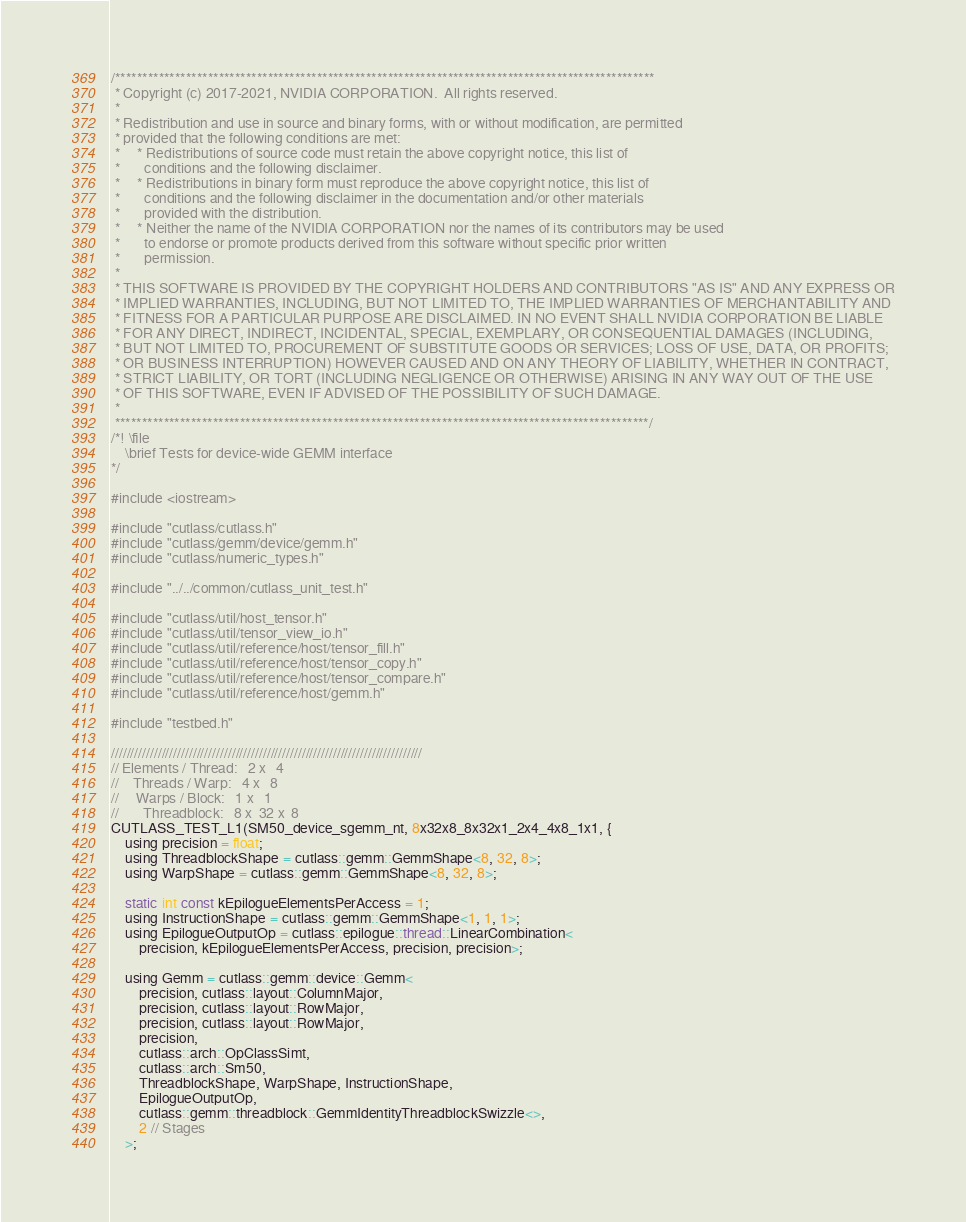Convert code to text. <code><loc_0><loc_0><loc_500><loc_500><_Cuda_>/***************************************************************************************************
 * Copyright (c) 2017-2021, NVIDIA CORPORATION.  All rights reserved.
 *
 * Redistribution and use in source and binary forms, with or without modification, are permitted
 * provided that the following conditions are met:
 *     * Redistributions of source code must retain the above copyright notice, this list of
 *       conditions and the following disclaimer.
 *     * Redistributions in binary form must reproduce the above copyright notice, this list of
 *       conditions and the following disclaimer in the documentation and/or other materials
 *       provided with the distribution.
 *     * Neither the name of the NVIDIA CORPORATION nor the names of its contributors may be used
 *       to endorse or promote products derived from this software without specific prior written
 *       permission.
 *
 * THIS SOFTWARE IS PROVIDED BY THE COPYRIGHT HOLDERS AND CONTRIBUTORS "AS IS" AND ANY EXPRESS OR
 * IMPLIED WARRANTIES, INCLUDING, BUT NOT LIMITED TO, THE IMPLIED WARRANTIES OF MERCHANTABILITY AND
 * FITNESS FOR A PARTICULAR PURPOSE ARE DISCLAIMED. IN NO EVENT SHALL NVIDIA CORPORATION BE LIABLE
 * FOR ANY DIRECT, INDIRECT, INCIDENTAL, SPECIAL, EXEMPLARY, OR CONSEQUENTIAL DAMAGES (INCLUDING,
 * BUT NOT LIMITED TO, PROCUREMENT OF SUBSTITUTE GOODS OR SERVICES; LOSS OF USE, DATA, OR PROFITS;
 * OR BUSINESS INTERRUPTION) HOWEVER CAUSED AND ON ANY THEORY OF LIABILITY, WHETHER IN CONTRACT,
 * STRICT LIABILITY, OR TORT (INCLUDING NEGLIGENCE OR OTHERWISE) ARISING IN ANY WAY OUT OF THE USE
 * OF THIS SOFTWARE, EVEN IF ADVISED OF THE POSSIBILITY OF SUCH DAMAGE.
 *
 **************************************************************************************************/
/*! \file
    \brief Tests for device-wide GEMM interface
*/

#include <iostream>

#include "cutlass/cutlass.h"
#include "cutlass/gemm/device/gemm.h"
#include "cutlass/numeric_types.h"

#include "../../common/cutlass_unit_test.h"

#include "cutlass/util/host_tensor.h"
#include "cutlass/util/tensor_view_io.h"
#include "cutlass/util/reference/host/tensor_fill.h"
#include "cutlass/util/reference/host/tensor_copy.h"
#include "cutlass/util/reference/host/tensor_compare.h"
#include "cutlass/util/reference/host/gemm.h"

#include "testbed.h"

////////////////////////////////////////////////////////////////////////////////
// Elements / Thread:   2 x   4
//    Threads / Warp:   4 x   8
//     Warps / Block:   1 x   1
//       Threadblock:   8 x  32 x  8
CUTLASS_TEST_L1(SM50_device_sgemm_nt, 8x32x8_8x32x1_2x4_4x8_1x1, {
    using precision = float;
    using ThreadblockShape = cutlass::gemm::GemmShape<8, 32, 8>;
    using WarpShape = cutlass::gemm::GemmShape<8, 32, 8>;

    static int const kEpilogueElementsPerAccess = 1;
    using InstructionShape = cutlass::gemm::GemmShape<1, 1, 1>;
    using EpilogueOutputOp = cutlass::epilogue::thread::LinearCombination<
        precision, kEpilogueElementsPerAccess, precision, precision>;

    using Gemm = cutlass::gemm::device::Gemm<
        precision, cutlass::layout::ColumnMajor,
        precision, cutlass::layout::RowMajor,
        precision, cutlass::layout::RowMajor,
        precision,
        cutlass::arch::OpClassSimt,
        cutlass::arch::Sm50,
        ThreadblockShape, WarpShape, InstructionShape,
        EpilogueOutputOp,
        cutlass::gemm::threadblock::GemmIdentityThreadblockSwizzle<>,
        2 // Stages
    >;</code> 